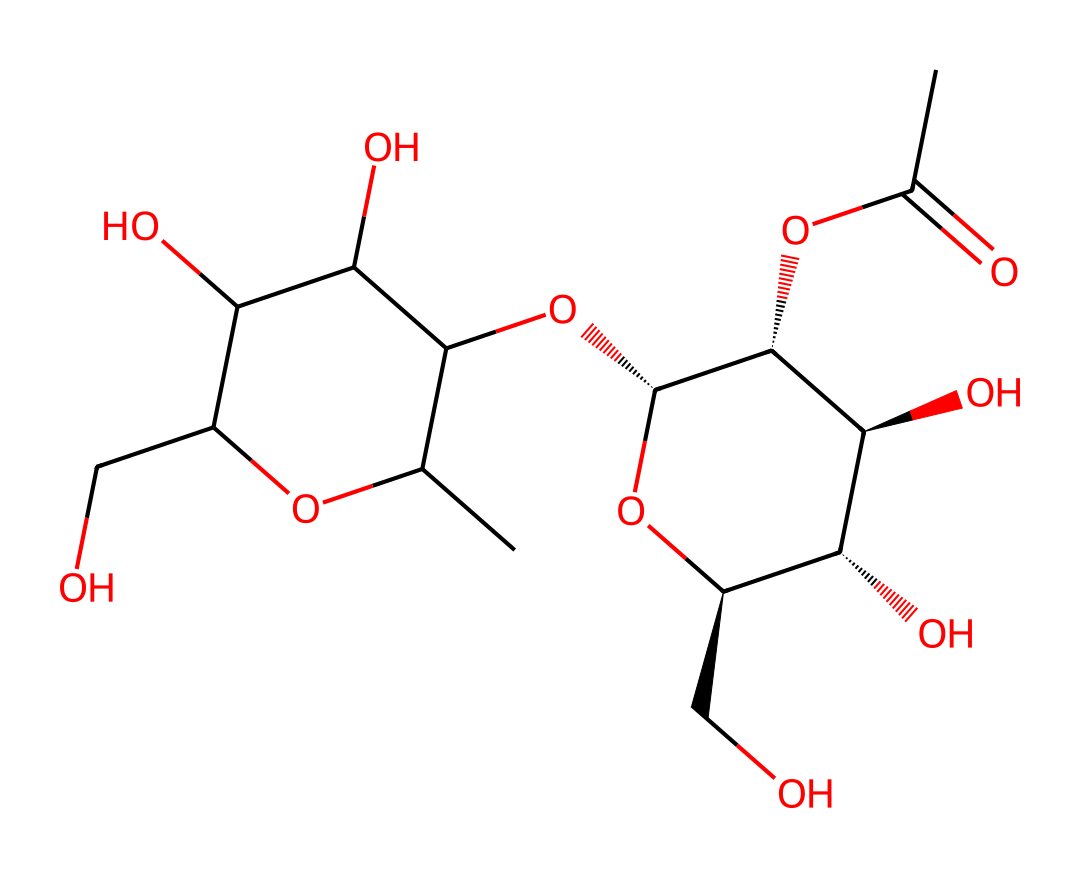What is the main functional group present in this chemical structure? The structure contains a carboxyl group (–COOH), which is typically found in organic acids and contributes to pectin's gelling properties. This can be identified by locating the part of the molecule where a carbon is connected to both a hydroxyl group (–OH) and a carbonyl group (C=O).
Answer: carboxyl group How many hydroxyl groups are present in this chemical? By examining the structural representation, we can identify each –OH group. In this structure, there are five –OH groups connected to carbon atoms, which can be counted directly from the structure.
Answer: five What type of glycosidic linkages are likely present in pectin? Pectin mainly consists of galacturonic acid units connected by α (1→4) glycosidic linkages, and this can be inferred by looking at the connections between the sugar units in the structure.
Answer: α (1→4) glycosidic linkages Does this structure indicate the potential for gel-forming properties? Yes, the presence of multiple hydroxyl groups and the specific arrangement of sugar units suggest that this structure can interact with water molecules effectively, which is essential for forming gels. This is a fundamental trait of pectin's gelling behavior.
Answer: Yes Can the given structure represent a form of pectin used in traditional Indian sweets? The SMILES representation indicates a complex structure typical of pectin found in fruits, which is indeed used in traditional Indian sweets like halwa and other desserts for their gelling and thickening properties.
Answer: Yes 